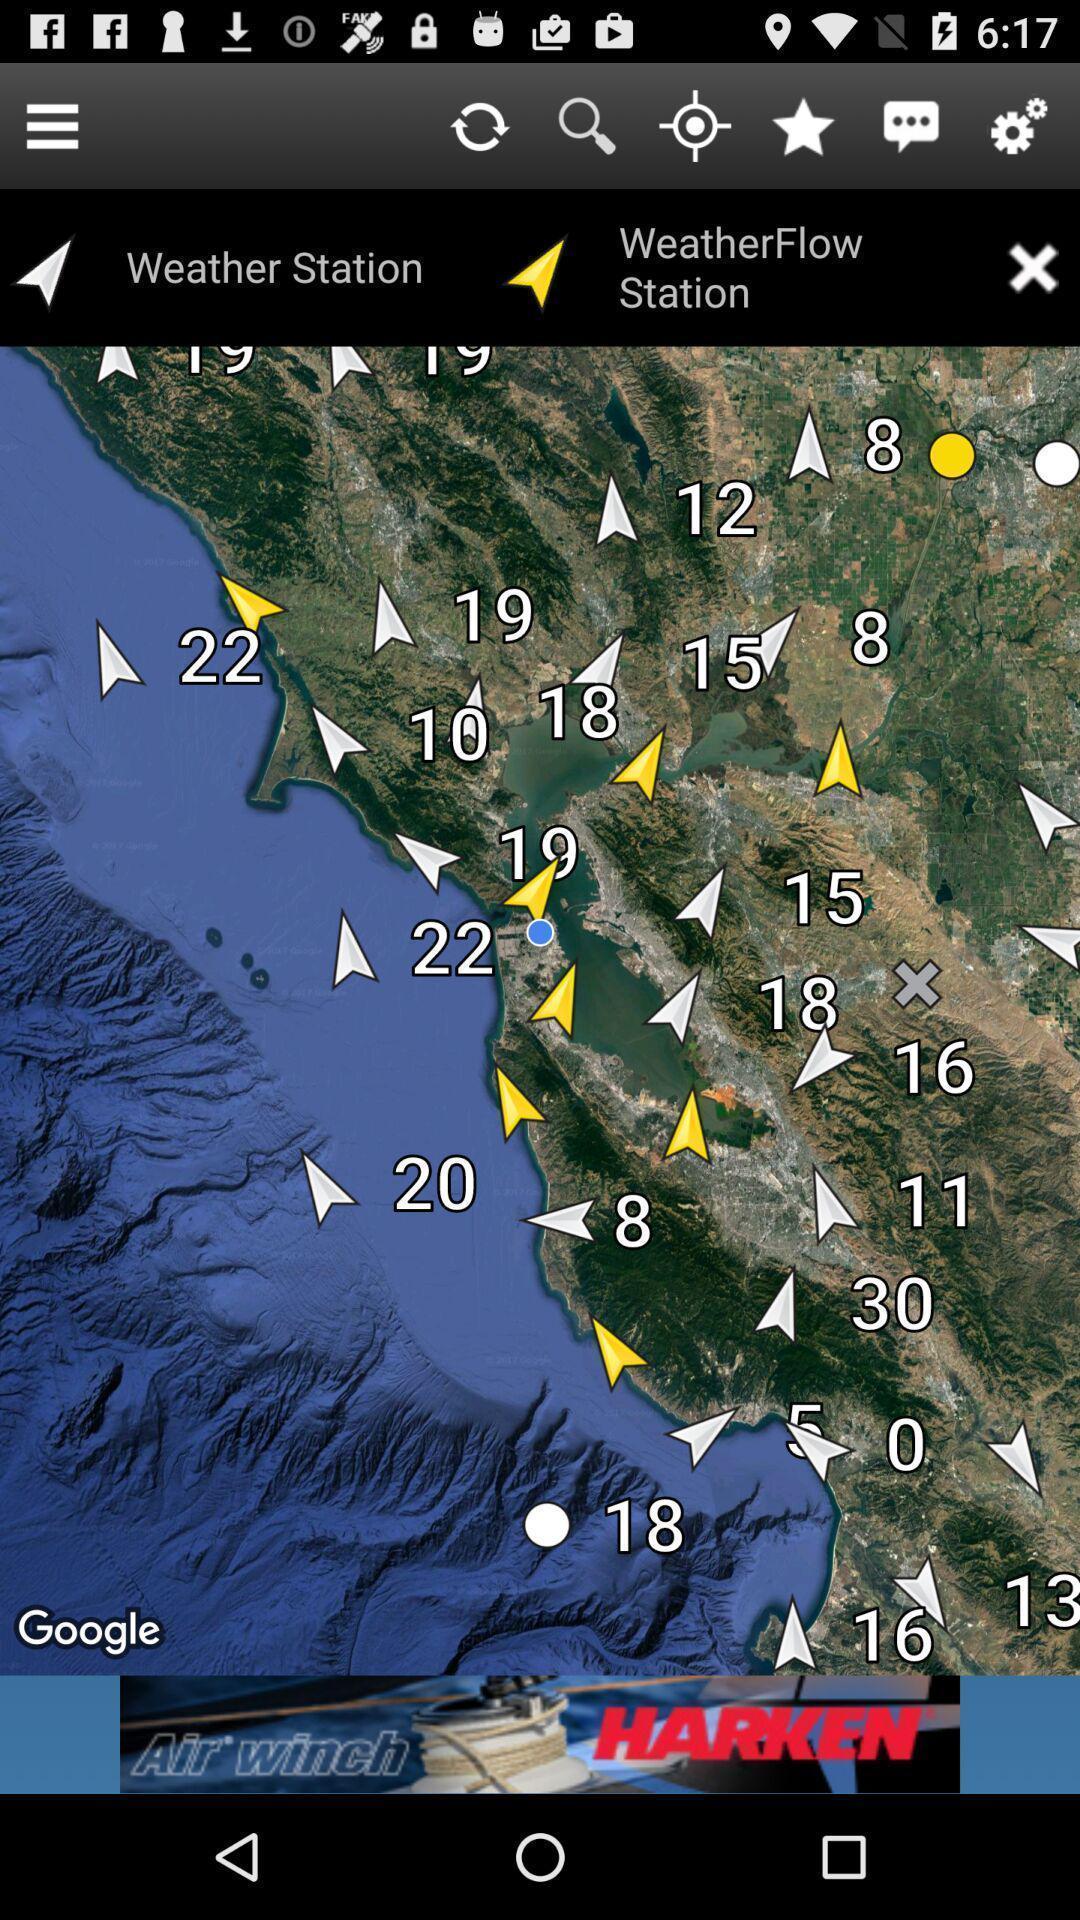Provide a description of this screenshot. Screen showing weather report. 